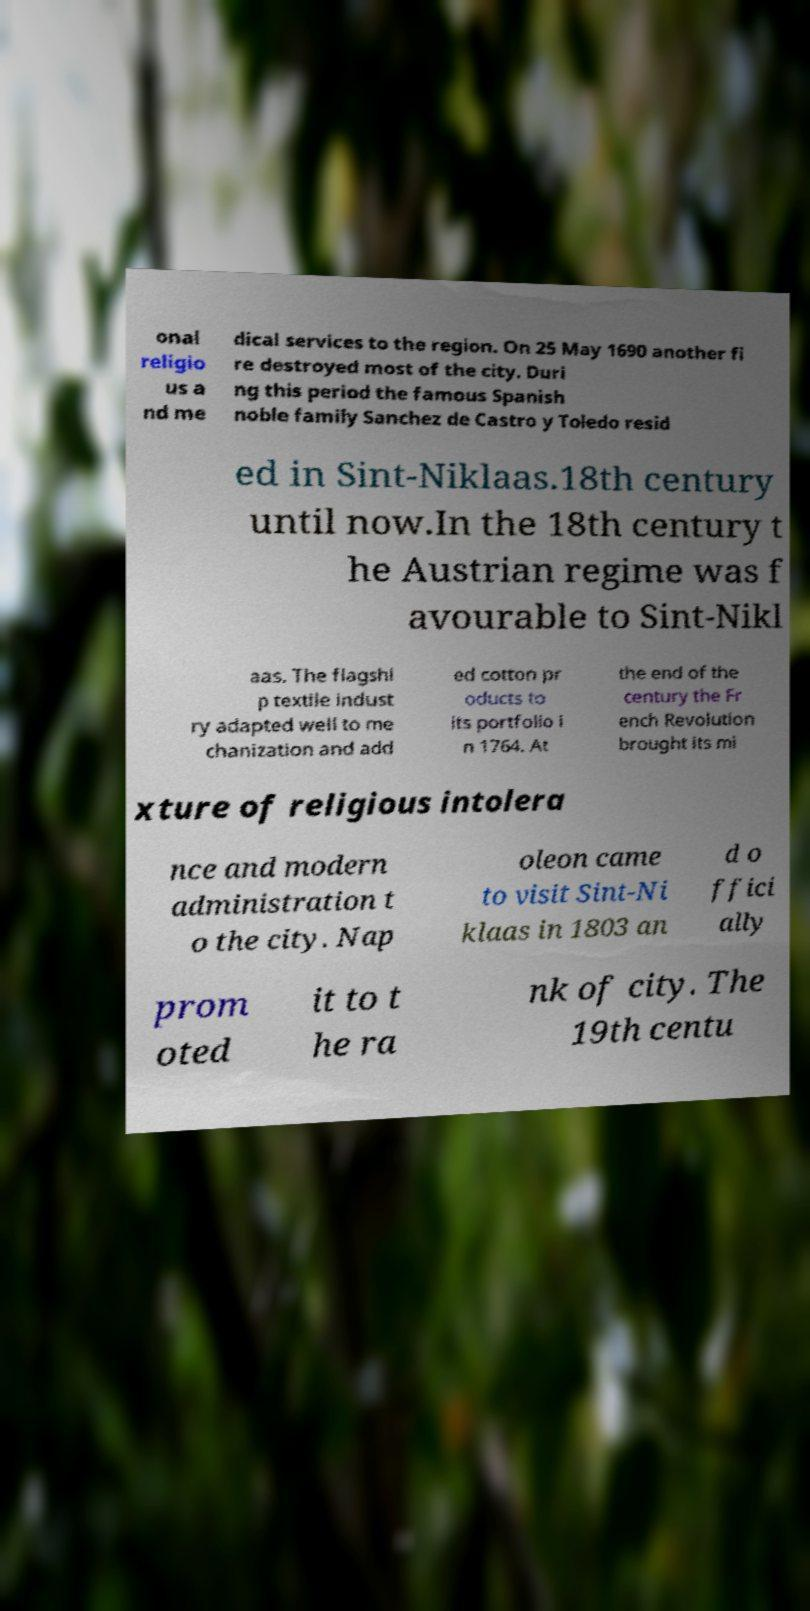Could you assist in decoding the text presented in this image and type it out clearly? onal religio us a nd me dical services to the region. On 25 May 1690 another fi re destroyed most of the city. Duri ng this period the famous Spanish noble family Sanchez de Castro y Toledo resid ed in Sint-Niklaas.18th century until now.In the 18th century t he Austrian regime was f avourable to Sint-Nikl aas. The flagshi p textile indust ry adapted well to me chanization and add ed cotton pr oducts to its portfolio i n 1764. At the end of the century the Fr ench Revolution brought its mi xture of religious intolera nce and modern administration t o the city. Nap oleon came to visit Sint-Ni klaas in 1803 an d o ffici ally prom oted it to t he ra nk of city. The 19th centu 